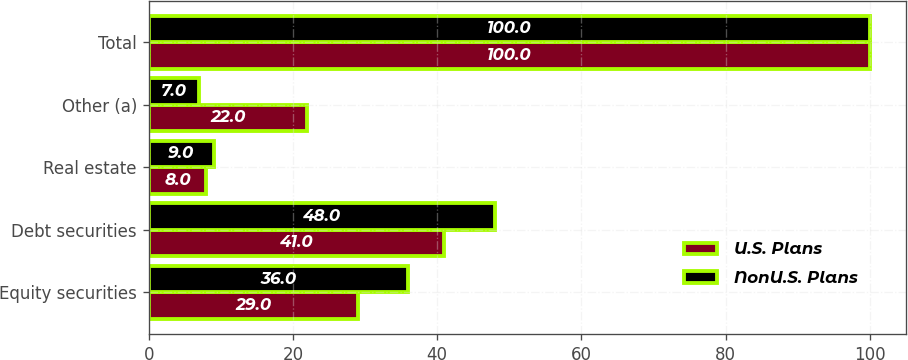Convert chart. <chart><loc_0><loc_0><loc_500><loc_500><stacked_bar_chart><ecel><fcel>Equity securities<fcel>Debt securities<fcel>Real estate<fcel>Other (a)<fcel>Total<nl><fcel>U.S. Plans<fcel>29<fcel>41<fcel>8<fcel>22<fcel>100<nl><fcel>NonU.S. Plans<fcel>36<fcel>48<fcel>9<fcel>7<fcel>100<nl></chart> 